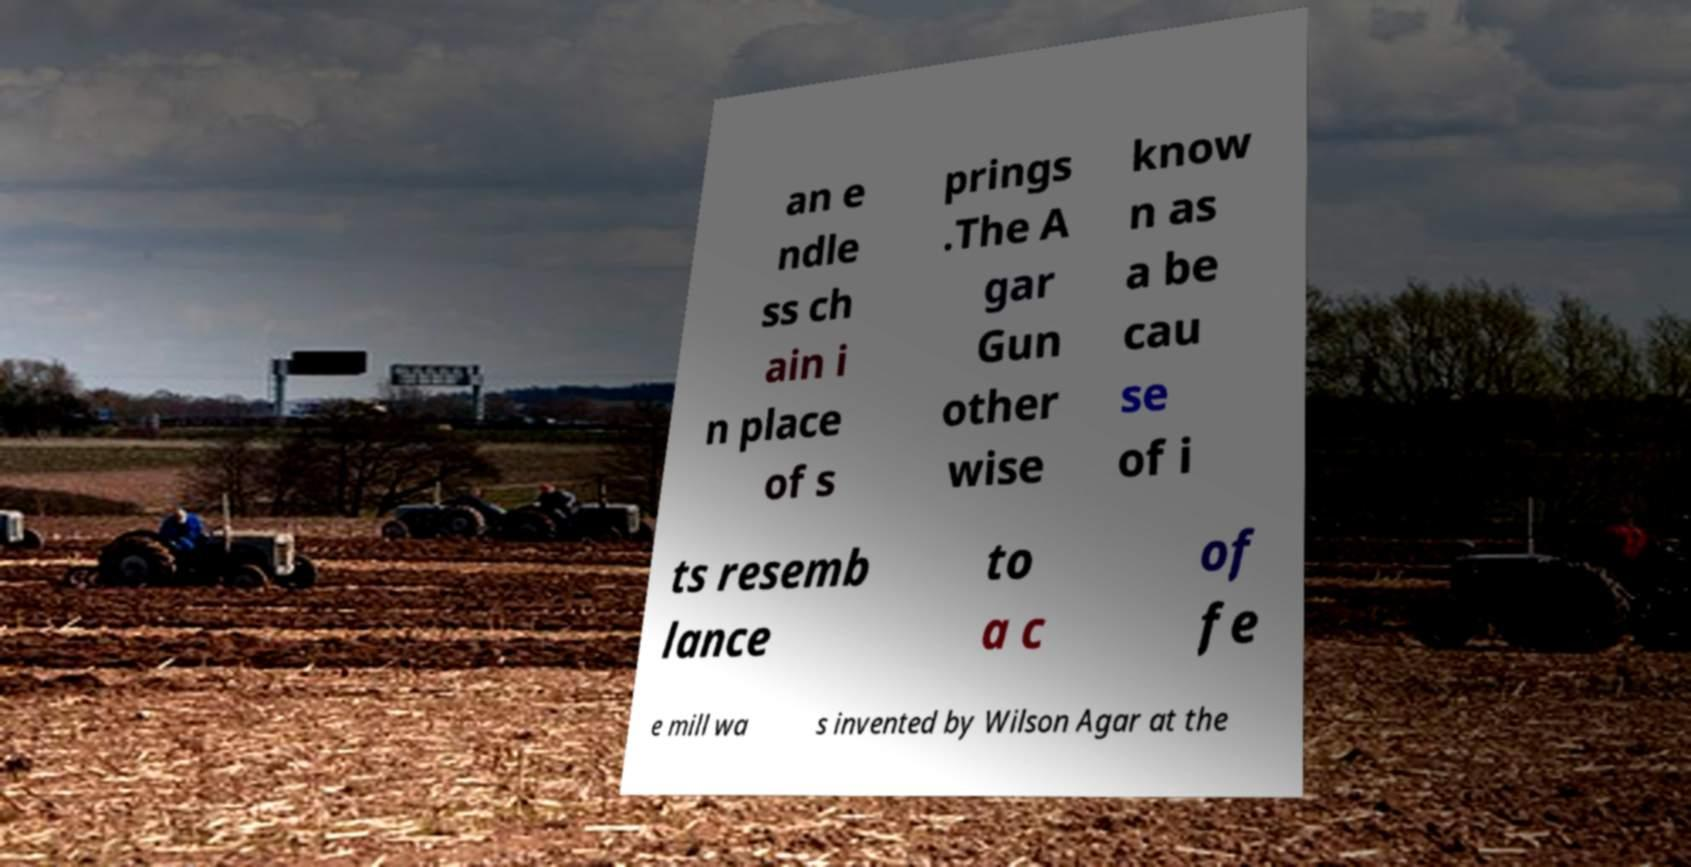Could you extract and type out the text from this image? an e ndle ss ch ain i n place of s prings .The A gar Gun other wise know n as a be cau se of i ts resemb lance to a c of fe e mill wa s invented by Wilson Agar at the 